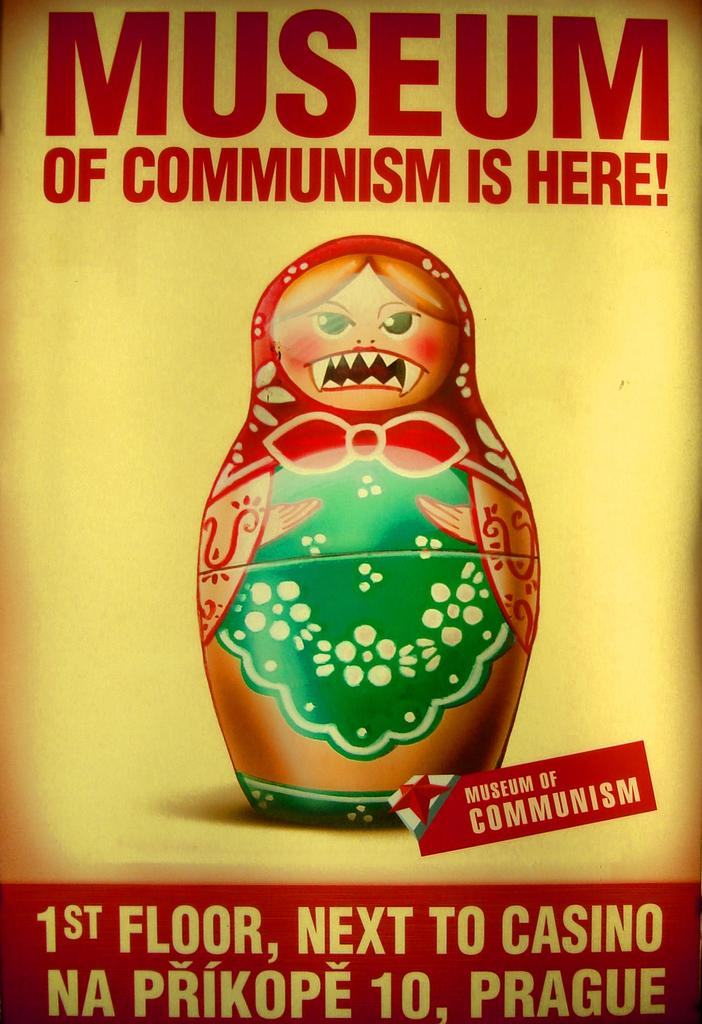What type of visual is the image? The image is a poster. What can be found on the poster besides the photo? There are words and numbers on the poster. What is depicted in the photo on the poster? There is a photo of a toy on the poster. Can you see your friend playing volleyball in the poster? There is no friend or volleyball depicted in the poster; it features words, numbers, and a photo of a toy. 